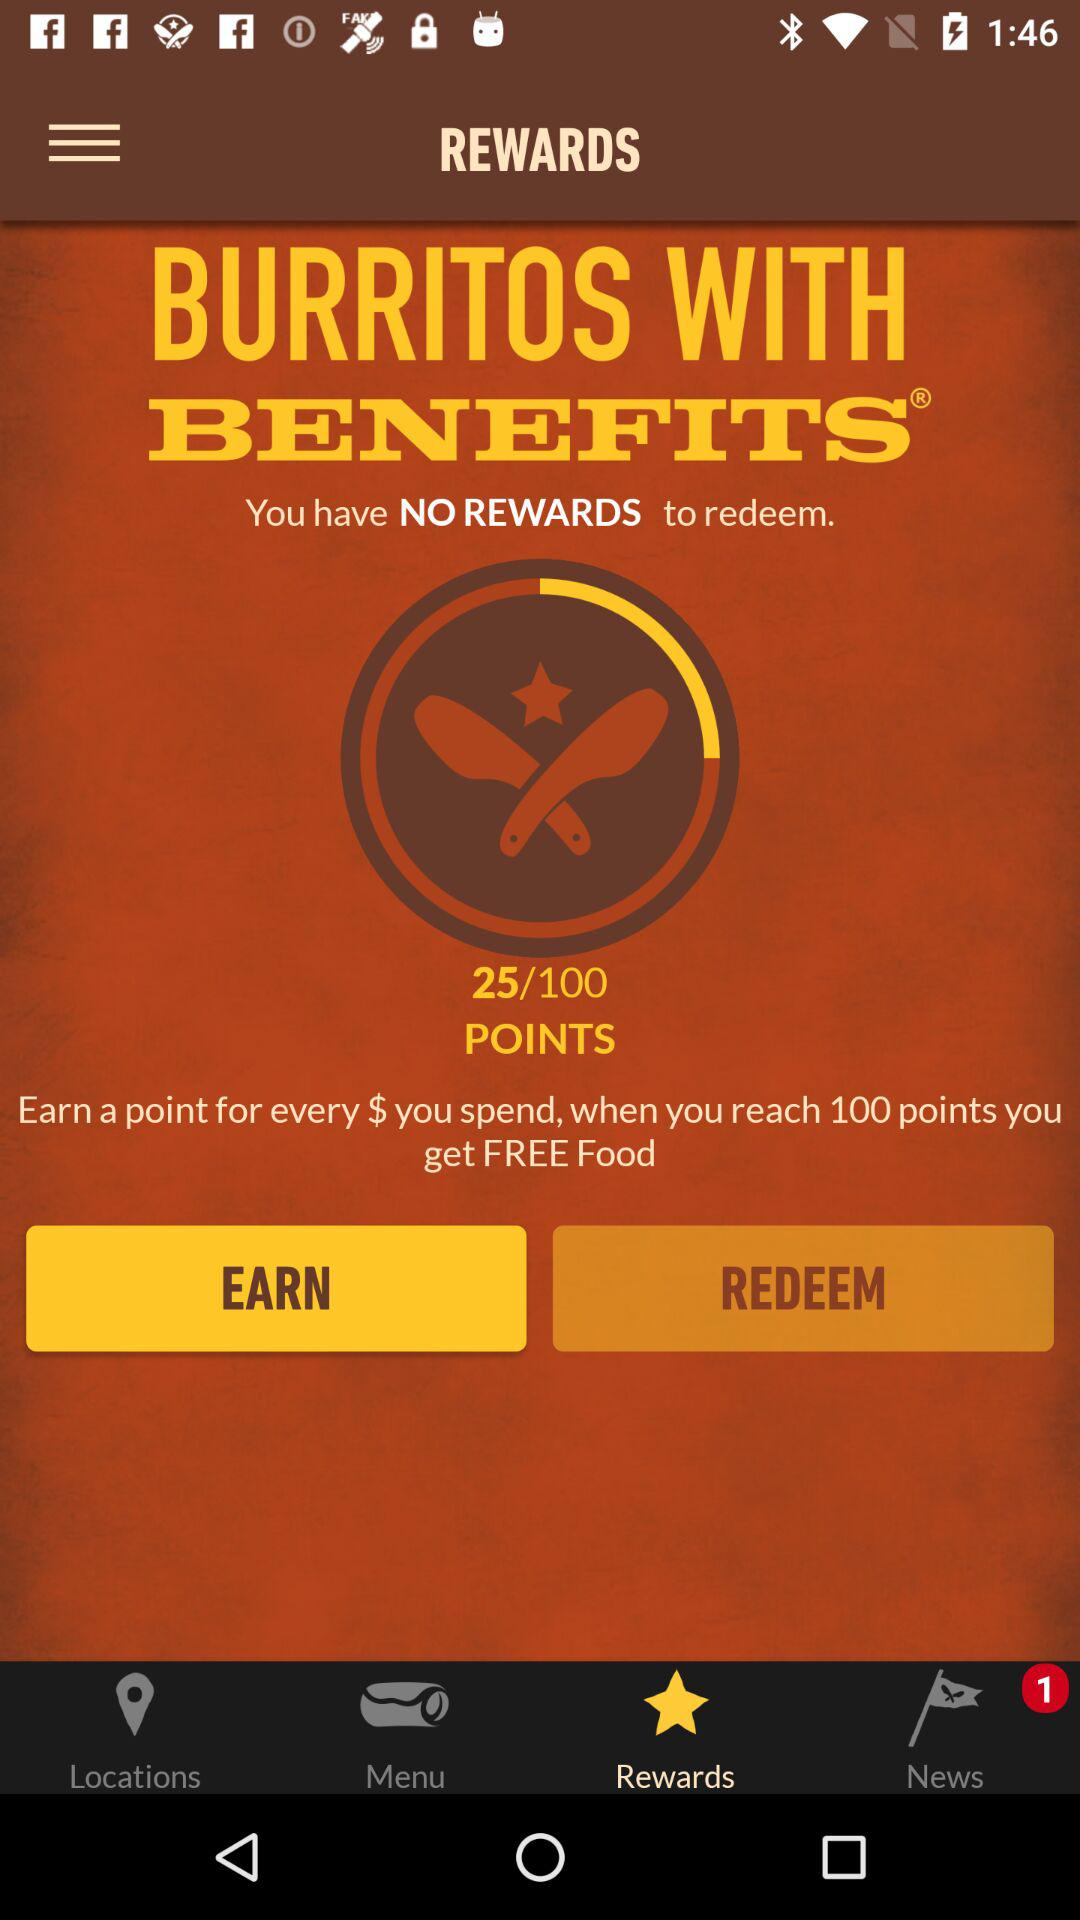How many points do I need to redeem a reward?
Answer the question using a single word or phrase. 100 